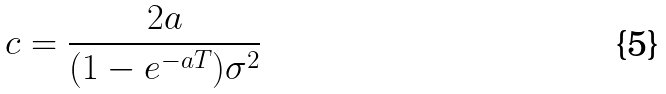Convert formula to latex. <formula><loc_0><loc_0><loc_500><loc_500>c = \frac { 2 a } { ( 1 - e ^ { - a T } ) \sigma ^ { 2 } }</formula> 